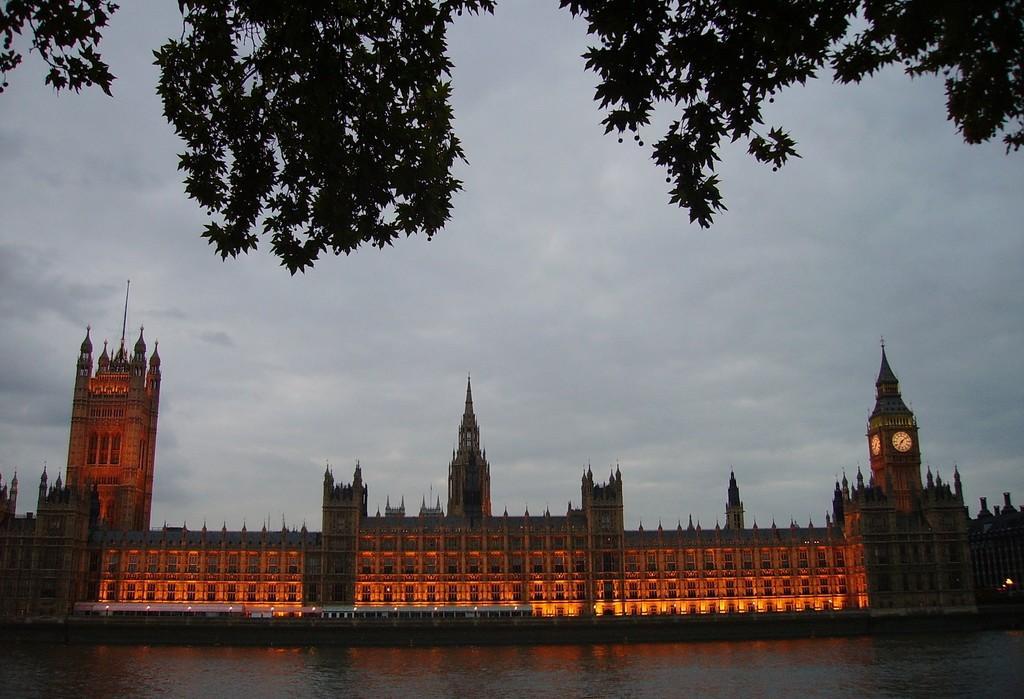How would you summarize this image in a sentence or two? In this image I can see a building,clock tower,vehicles,water and trees. I can see the orange and yellow lighting. The sky is in blue and white color. 